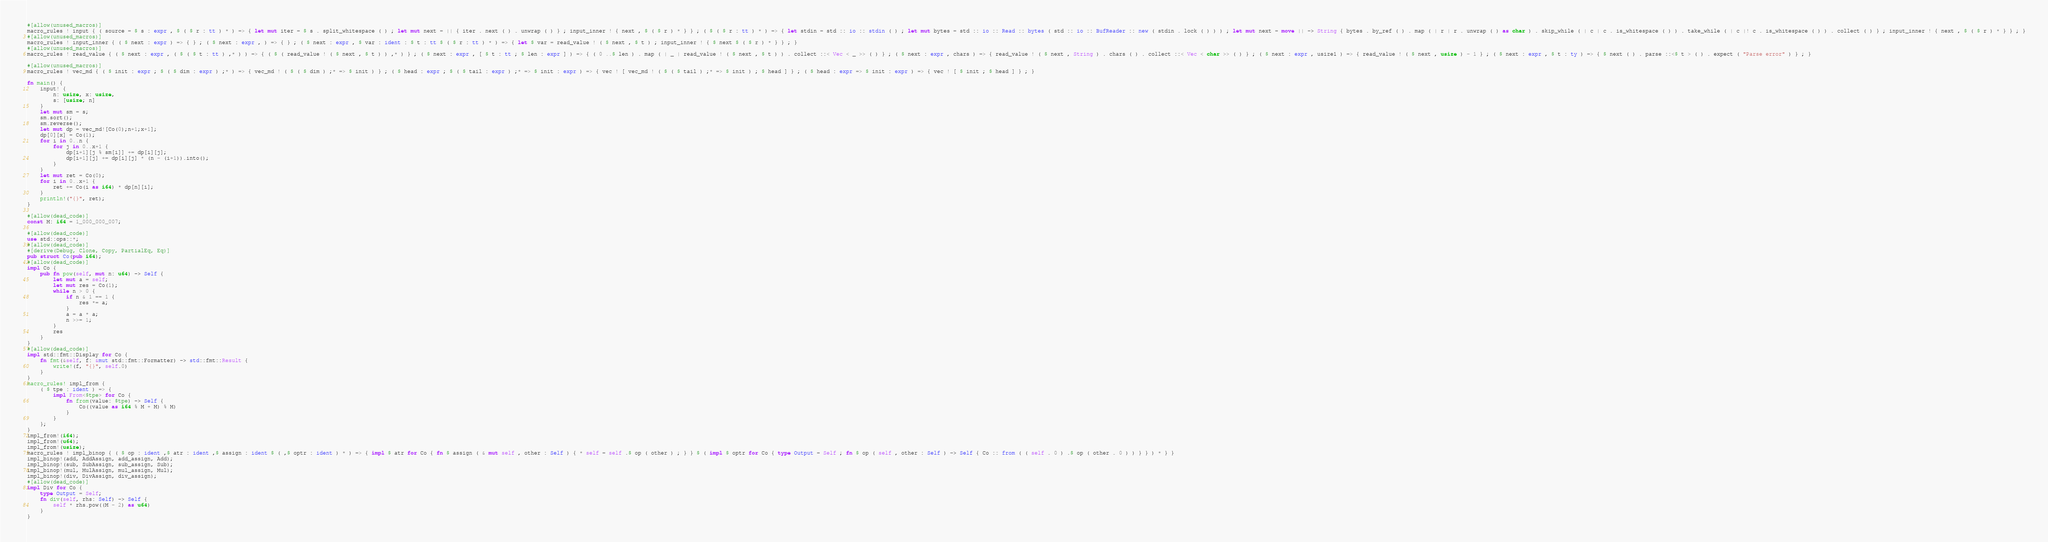Convert code to text. <code><loc_0><loc_0><loc_500><loc_500><_Rust_>#[allow(unused_macros)]
macro_rules ! input { ( source = $ s : expr , $ ( $ r : tt ) * ) => { let mut iter = $ s . split_whitespace ( ) ; let mut next = || { iter . next ( ) . unwrap ( ) } ; input_inner ! { next , $ ( $ r ) * } } ; ( $ ( $ r : tt ) * ) => { let stdin = std :: io :: stdin ( ) ; let mut bytes = std :: io :: Read :: bytes ( std :: io :: BufReader :: new ( stdin . lock ( ) ) ) ; let mut next = move || -> String { bytes . by_ref ( ) . map ( | r | r . unwrap ( ) as char ) . skip_while ( | c | c . is_whitespace ( ) ) . take_while ( | c |! c . is_whitespace ( ) ) . collect ( ) } ; input_inner ! { next , $ ( $ r ) * } } ; }
#[allow(unused_macros)]
macro_rules ! input_inner { ( $ next : expr ) => { } ; ( $ next : expr , ) => { } ; ( $ next : expr , $ var : ident : $ t : tt $ ( $ r : tt ) * ) => { let $ var = read_value ! ( $ next , $ t ) ; input_inner ! { $ next $ ( $ r ) * } } ; }
#[allow(unused_macros)]
macro_rules ! read_value { ( $ next : expr , ( $ ( $ t : tt ) ,* ) ) => { ( $ ( read_value ! ( $ next , $ t ) ) ,* ) } ; ( $ next : expr , [ $ t : tt ; $ len : expr ] ) => { ( 0 ..$ len ) . map ( | _ | read_value ! ( $ next , $ t ) ) . collect ::< Vec < _ >> ( ) } ; ( $ next : expr , chars ) => { read_value ! ( $ next , String ) . chars ( ) . collect ::< Vec < char >> ( ) } ; ( $ next : expr , usize1 ) => { read_value ! ( $ next , usize ) - 1 } ; ( $ next : expr , $ t : ty ) => { $ next ( ) . parse ::<$ t > ( ) . expect ( "Parse error" ) } ; }

#[allow(unused_macros)]
macro_rules ! vec_md { ( $ init : expr ; $ ( $ dim : expr ) ;* ) => { vec_md ! ( $ ( $ dim ) ;* => $ init ) } ; ( $ head : expr ; $ ( $ tail : expr ) ;* => $ init : expr ) => { vec ! [ vec_md ! ( $ ( $ tail ) ;* => $ init ) ; $ head ] } ; ( $ head : expr => $ init : expr ) => { vec ! [ $ init ; $ head ] } ; }

fn main() {
    input! {
        n: usize, x: usize,
        s: [usize; n]
    }
    let mut sm = s;
    sm.sort();
    sm.reverse();
    let mut dp = vec_md![Co(0);n+1;x+1];
    dp[0][x] = Co(1);
    for i in 0..n {
        for j in 0..x+1 {
            dp[i+1][j % sm[i]] += dp[i][j];
            dp[i+1][j] += dp[i][j] * (n - (i+1)).into();
        }
    }
    let mut ret = Co(0);
    for i in 0..x+1 {
        ret += Co(i as i64) * dp[n][i];
    }
    println!("{}", ret);
}

#[allow(dead_code)]
const M: i64 = 1_000_000_007;

#[allow(dead_code)]
use std::ops::*;
#[allow(dead_code)]
#[derive(Debug, Clone, Copy, PartialEq, Eq)]
pub struct Co(pub i64);
#[allow(dead_code)]
impl Co {
    pub fn pow(self, mut n: u64) -> Self {
        let mut a = self;
        let mut res = Co(1);
        while n > 0 {
            if n & 1 == 1 {
                res *= a;
            }
            a = a * a;
            n >>= 1;
        }
        res
    }
}
#[allow(dead_code)]
impl std::fmt::Display for Co {
    fn fmt(&self, f: &mut std::fmt::Formatter) -> std::fmt::Result {
        write!(f, "{}", self.0)
    }
}
macro_rules! impl_from {
    ( $ tpe : ident ) => {
        impl From<$tpe> for Co {
            fn from(value: $tpe) -> Self {
                Co((value as i64 % M + M) % M)
            }
        }
    };
}
impl_from!(i64);
impl_from!(u64);
impl_from!(usize);
macro_rules ! impl_binop { ( $ op : ident ,$ atr : ident ,$ assign : ident $ ( ,$ optr : ident ) * ) => { impl $ atr for Co { fn $ assign ( & mut self , other : Self ) { * self = self .$ op ( other ) ; } } $ ( impl $ optr for Co { type Output = Self ; fn $ op ( self , other : Self ) -> Self { Co :: from ( ( self . 0 ) .$ op ( other . 0 ) ) } } ) * } }
impl_binop!(add, AddAssign, add_assign, Add);
impl_binop!(sub, SubAssign, sub_assign, Sub);
impl_binop!(mul, MulAssign, mul_assign, Mul);
impl_binop!(div, DivAssign, div_assign);
#[allow(dead_code)]
impl Div for Co {
    type Output = Self;
    fn div(self, rhs: Self) -> Self {
        self * rhs.pow((M - 2) as u64)
    }
}</code> 